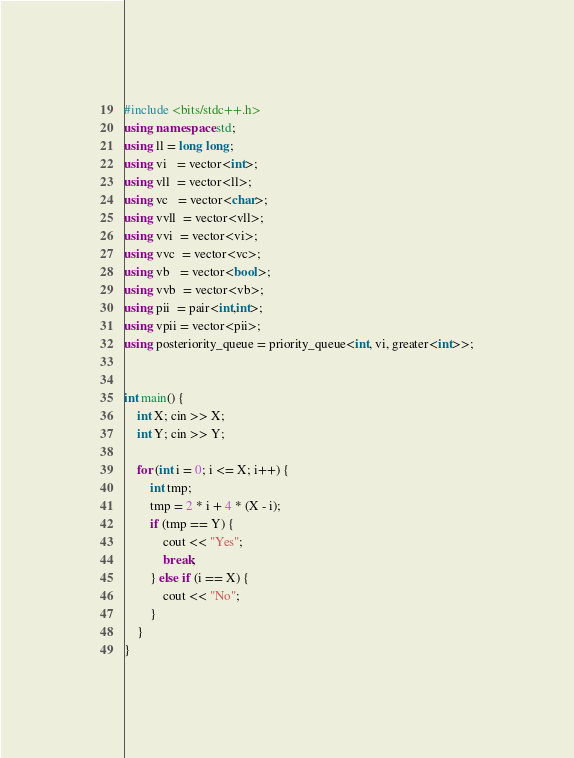Convert code to text. <code><loc_0><loc_0><loc_500><loc_500><_C++_>#include <bits/stdc++.h>
using namespace std;
using ll = long long;
using vi   = vector<int>;
using vll  = vector<ll>;
using vc   = vector<char>;
using vvll  = vector<vll>;
using vvi  = vector<vi>;
using vvc  = vector<vc>;
using vb   = vector<bool>;
using vvb  = vector<vb>;
using pii  = pair<int,int>;
using vpii = vector<pii>;
using posteriority_queue = priority_queue<int, vi, greater<int>>;


int main() {
    int X; cin >> X;
    int Y; cin >> Y;

    for (int i = 0; i <= X; i++) {
        int tmp;
        tmp = 2 * i + 4 * (X - i);
        if (tmp == Y) {
            cout << "Yes";
            break;
        } else if (i == X) {
            cout << "No";
        }
    }
}
</code> 